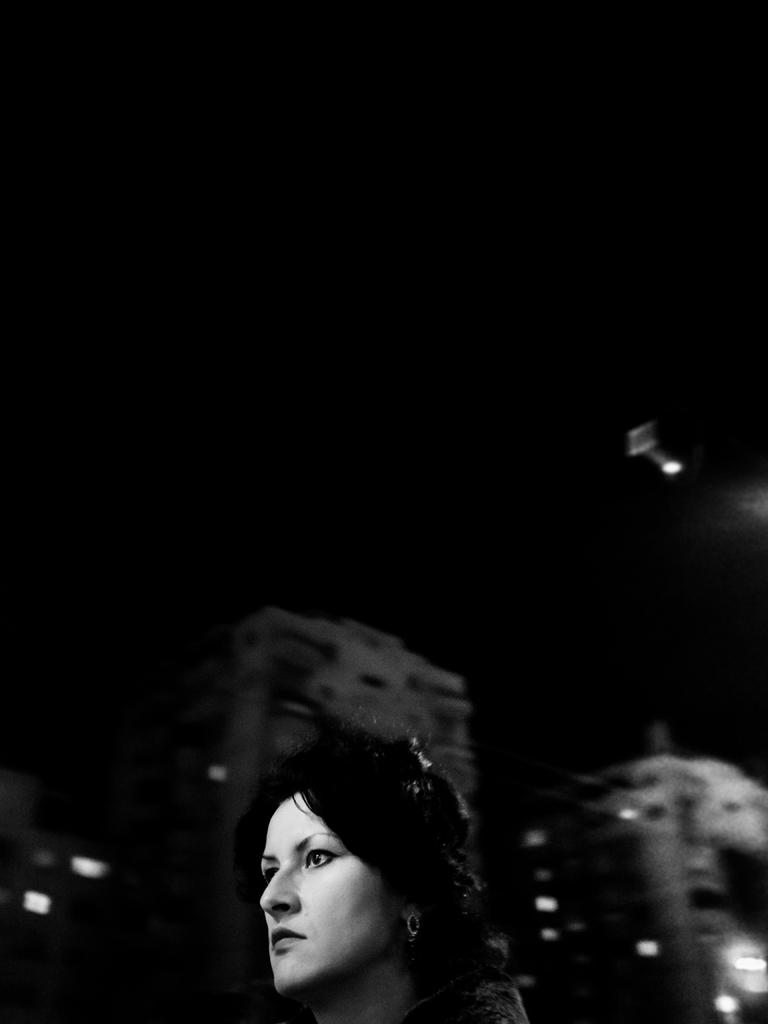What type of picture is in the image? The image contains a black and white picture. What is the subject of the black and white picture? The picture depicts a woman's head. What can be seen in the background of the black and white picture? There are buildings and lights visible in the background. How would you describe the sky in the background of the black and white picture? The sky in the background of the black and white picture is dark. How many bikes are parked next to the cactus in the image? There are no bikes or cactus present in the image; it contains a black and white picture of a woman's head with buildings and lights in the background. 